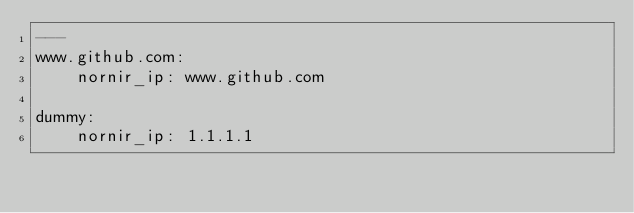Convert code to text. <code><loc_0><loc_0><loc_500><loc_500><_YAML_>---
www.github.com:
    nornir_ip: www.github.com

dummy:
    nornir_ip: 1.1.1.1
</code> 